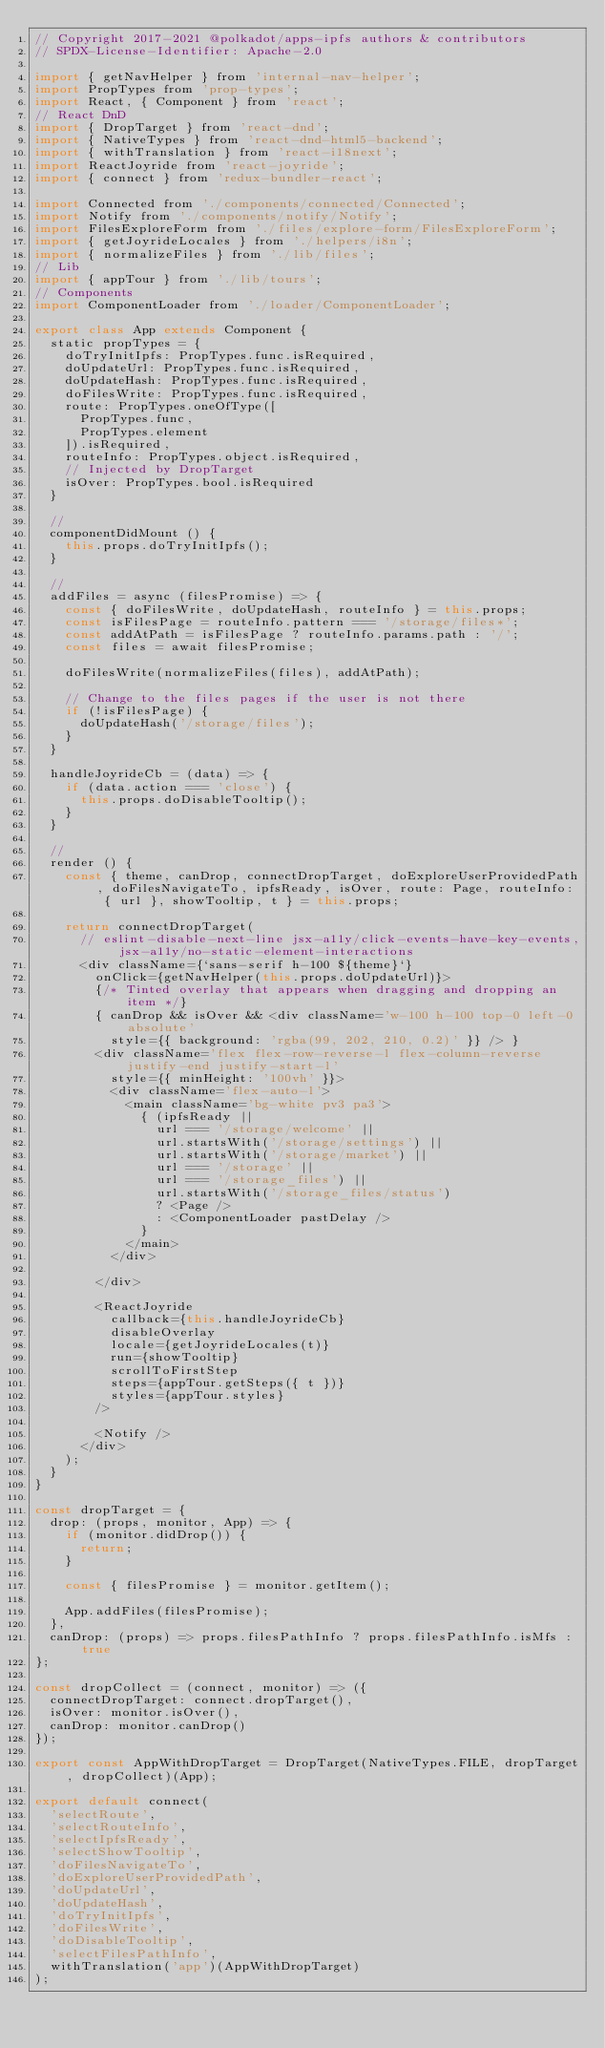Convert code to text. <code><loc_0><loc_0><loc_500><loc_500><_JavaScript_>// Copyright 2017-2021 @polkadot/apps-ipfs authors & contributors
// SPDX-License-Identifier: Apache-2.0

import { getNavHelper } from 'internal-nav-helper';
import PropTypes from 'prop-types';
import React, { Component } from 'react';
// React DnD
import { DropTarget } from 'react-dnd';
import { NativeTypes } from 'react-dnd-html5-backend';
import { withTranslation } from 'react-i18next';
import ReactJoyride from 'react-joyride';
import { connect } from 'redux-bundler-react';

import Connected from './components/connected/Connected';
import Notify from './components/notify/Notify';
import FilesExploreForm from './files/explore-form/FilesExploreForm';
import { getJoyrideLocales } from './helpers/i8n';
import { normalizeFiles } from './lib/files';
// Lib
import { appTour } from './lib/tours';
// Components
import ComponentLoader from './loader/ComponentLoader';

export class App extends Component {
  static propTypes = {
    doTryInitIpfs: PropTypes.func.isRequired,
    doUpdateUrl: PropTypes.func.isRequired,
    doUpdateHash: PropTypes.func.isRequired,
    doFilesWrite: PropTypes.func.isRequired,
    route: PropTypes.oneOfType([
      PropTypes.func,
      PropTypes.element
    ]).isRequired,
    routeInfo: PropTypes.object.isRequired,
    // Injected by DropTarget
    isOver: PropTypes.bool.isRequired
  }

  //
  componentDidMount () {
    this.props.doTryInitIpfs();
  }

  //
  addFiles = async (filesPromise) => {
    const { doFilesWrite, doUpdateHash, routeInfo } = this.props;
    const isFilesPage = routeInfo.pattern === '/storage/files*';
    const addAtPath = isFilesPage ? routeInfo.params.path : '/';
    const files = await filesPromise;

    doFilesWrite(normalizeFiles(files), addAtPath);

    // Change to the files pages if the user is not there
    if (!isFilesPage) {
      doUpdateHash('/storage/files');
    }
  }

  handleJoyrideCb = (data) => {
    if (data.action === 'close') {
      this.props.doDisableTooltip();
    }
  }

  //
  render () {
    const { theme, canDrop, connectDropTarget, doExploreUserProvidedPath, doFilesNavigateTo, ipfsReady, isOver, route: Page, routeInfo: { url }, showTooltip, t } = this.props;

    return connectDropTarget(
      // eslint-disable-next-line jsx-a11y/click-events-have-key-events, jsx-a11y/no-static-element-interactions
      <div className={`sans-serif h-100 ${theme}`}
        onClick={getNavHelper(this.props.doUpdateUrl)}>
        {/* Tinted overlay that appears when dragging and dropping an item */}
        { canDrop && isOver && <div className='w-100 h-100 top-0 left-0 absolute'
          style={{ background: 'rgba(99, 202, 210, 0.2)' }} /> }
        <div className='flex flex-row-reverse-l flex-column-reverse justify-end justify-start-l'
          style={{ minHeight: '100vh' }}>
          <div className='flex-auto-l'>
            <main className='bg-white pv3 pa3'>
              { (ipfsReady ||
                url === '/storage/welcome' ||
                url.startsWith('/storage/settings') ||
                url.startsWith('/storage/market') ||
                url === '/storage' ||
                url === '/storage_files') ||
                url.startsWith('/storage_files/status')
                ? <Page />
                : <ComponentLoader pastDelay />
              }
            </main>
          </div>

        </div>

        <ReactJoyride
          callback={this.handleJoyrideCb}
          disableOverlay
          locale={getJoyrideLocales(t)}
          run={showTooltip}
          scrollToFirstStep
          steps={appTour.getSteps({ t })}
          styles={appTour.styles}
        />

        <Notify />
      </div>
    );
  }
}

const dropTarget = {
  drop: (props, monitor, App) => {
    if (monitor.didDrop()) {
      return;
    }

    const { filesPromise } = monitor.getItem();

    App.addFiles(filesPromise);
  },
  canDrop: (props) => props.filesPathInfo ? props.filesPathInfo.isMfs : true
};

const dropCollect = (connect, monitor) => ({
  connectDropTarget: connect.dropTarget(),
  isOver: monitor.isOver(),
  canDrop: monitor.canDrop()
});

export const AppWithDropTarget = DropTarget(NativeTypes.FILE, dropTarget, dropCollect)(App);

export default connect(
  'selectRoute',
  'selectRouteInfo',
  'selectIpfsReady',
  'selectShowTooltip',
  'doFilesNavigateTo',
  'doExploreUserProvidedPath',
  'doUpdateUrl',
  'doUpdateHash',
  'doTryInitIpfs',
  'doFilesWrite',
  'doDisableTooltip',
  'selectFilesPathInfo',
  withTranslation('app')(AppWithDropTarget)
);
</code> 